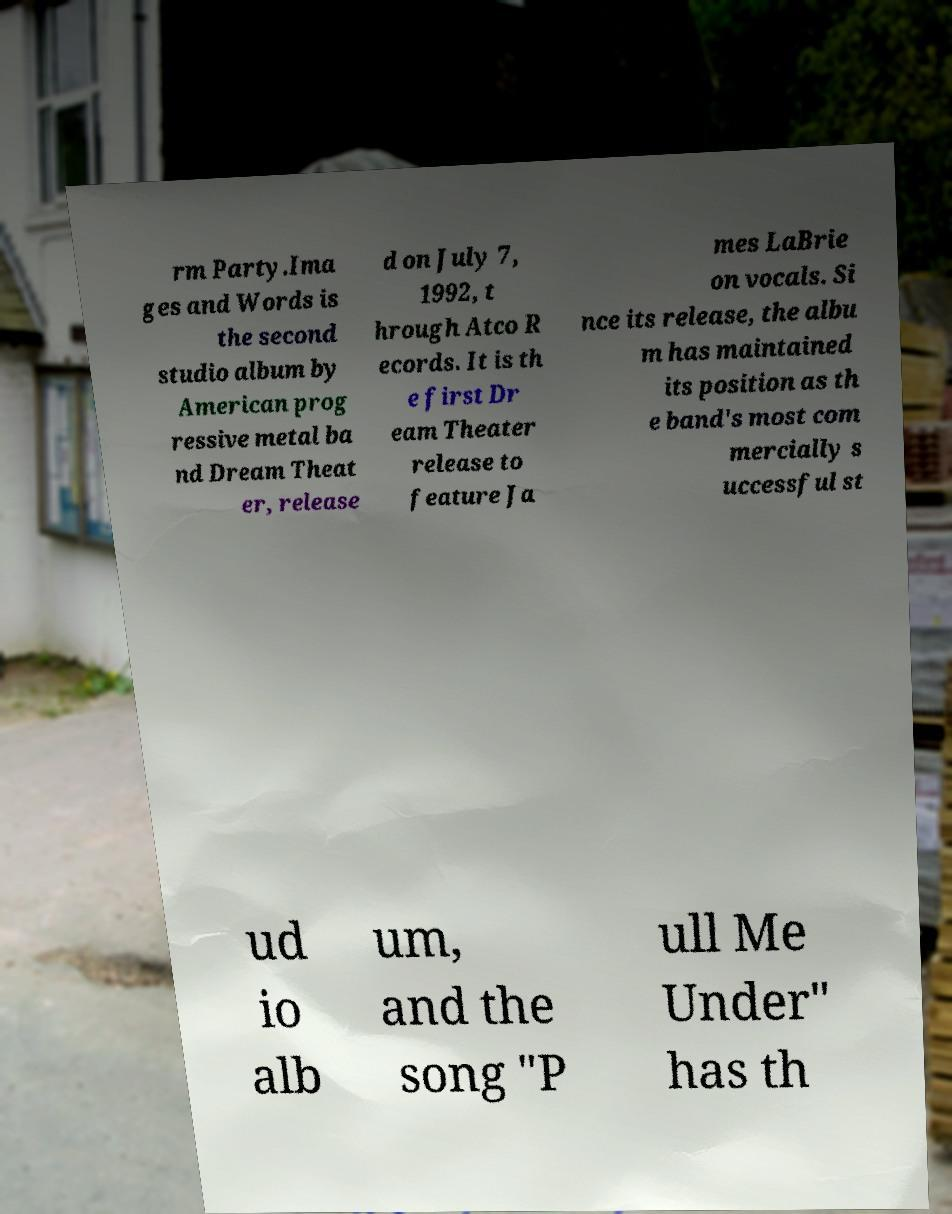I need the written content from this picture converted into text. Can you do that? rm Party.Ima ges and Words is the second studio album by American prog ressive metal ba nd Dream Theat er, release d on July 7, 1992, t hrough Atco R ecords. It is th e first Dr eam Theater release to feature Ja mes LaBrie on vocals. Si nce its release, the albu m has maintained its position as th e band's most com mercially s uccessful st ud io alb um, and the song "P ull Me Under" has th 